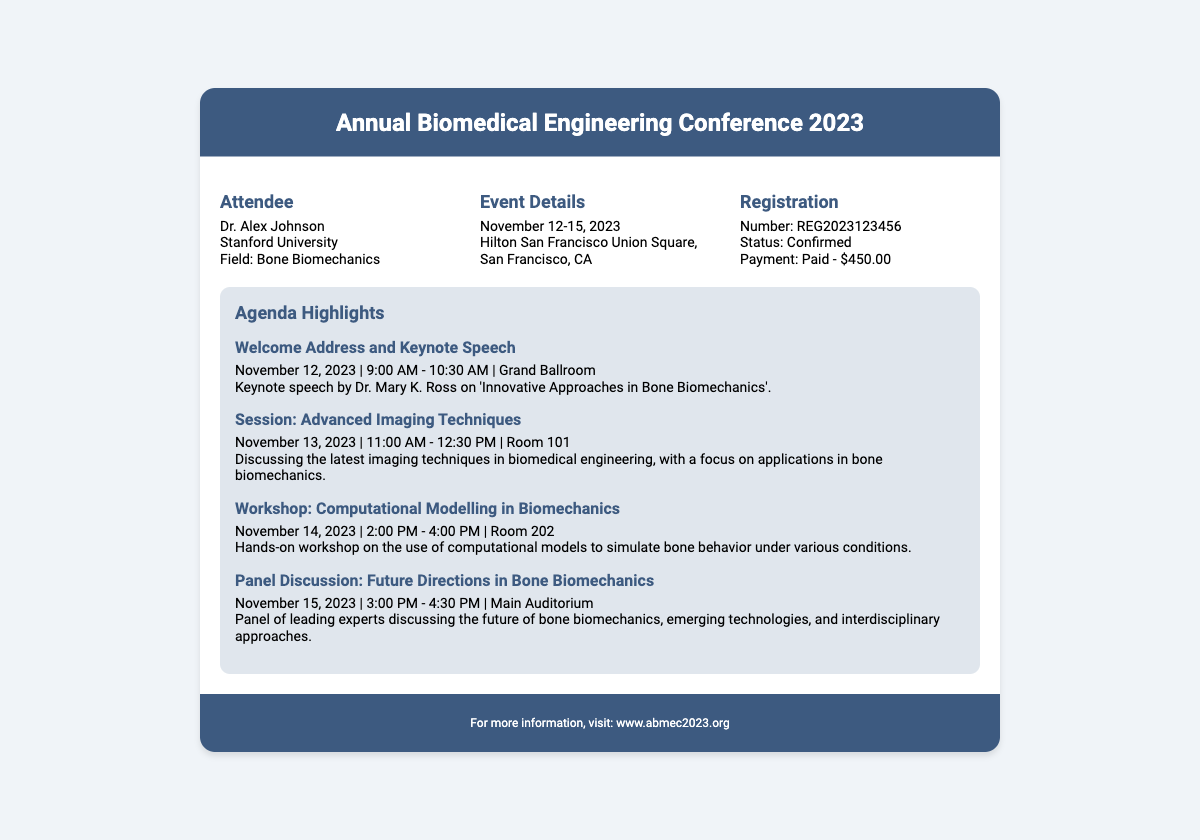what are the dates of the conference? The document specifies that the conference is scheduled to take place from November 12-15, 2023.
Answer: November 12-15, 2023 who is the keynote speaker? The document mentions that Dr. Mary K. Ross will deliver the keynote speech.
Answer: Dr. Mary K. Ross what is the registration number? The registration number listed in the document is REG2023123456.
Answer: REG2023123456 what is the payment status? According to the document, the payment status is confirmed and the payment amount is $450.00.
Answer: Paid - $450.00 what workshop is scheduled for November 14, 2023? The document outlines a workshop on computational modelling in biomechanics taking place on that date.
Answer: Computational Modelling in Biomechanics how long is the keynote speech? The document states that the welcome address and keynote speech will last for 1 hour and 30 minutes.
Answer: 1 hour 30 minutes which room hosts the session on advanced imaging techniques? The document indicates that the session on advanced imaging techniques is held in Room 101.
Answer: Room 101 what is the focus area of the panel discussion? The focus area for the panel discussion is future directions in bone biomechanics.
Answer: Future Directions in Bone Biomechanics where is the conference being held? The document specifies that the conference takes place at Hilton San Francisco Union Square, San Francisco, CA.
Answer: Hilton San Francisco Union Square, San Francisco, CA 